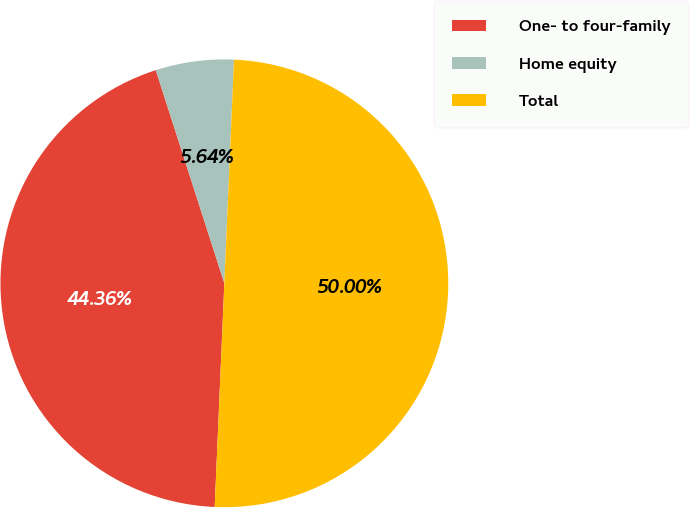Convert chart. <chart><loc_0><loc_0><loc_500><loc_500><pie_chart><fcel>One- to four-family<fcel>Home equity<fcel>Total<nl><fcel>44.36%<fcel>5.64%<fcel>50.0%<nl></chart> 